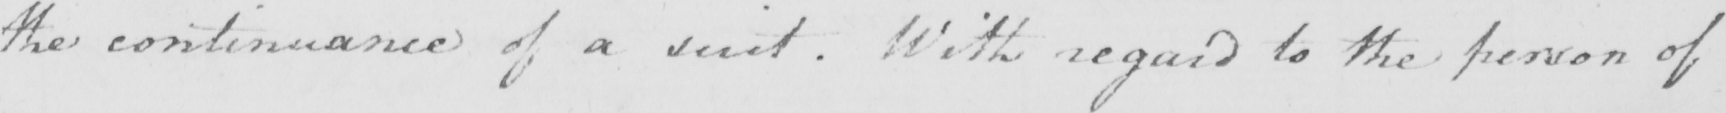Transcribe the text shown in this historical manuscript line. the continuance of a suit . With regard to the person of 